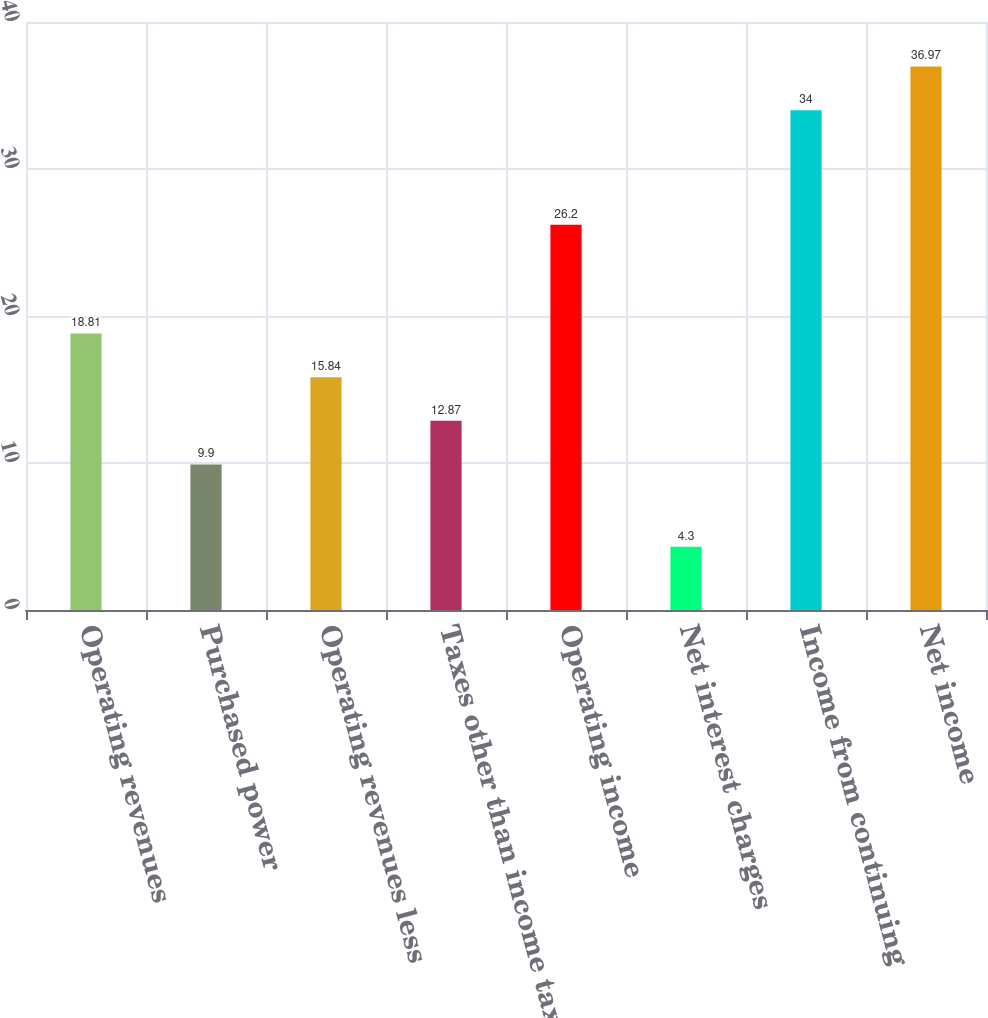<chart> <loc_0><loc_0><loc_500><loc_500><bar_chart><fcel>Operating revenues<fcel>Purchased power<fcel>Operating revenues less<fcel>Taxes other than income taxes<fcel>Operating income<fcel>Net interest charges<fcel>Income from continuing<fcel>Net income<nl><fcel>18.81<fcel>9.9<fcel>15.84<fcel>12.87<fcel>26.2<fcel>4.3<fcel>34<fcel>36.97<nl></chart> 